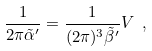Convert formula to latex. <formula><loc_0><loc_0><loc_500><loc_500>\frac { 1 } { 2 \pi { \tilde { \alpha } } ^ { \prime } } = \frac { 1 } { ( 2 \pi ) ^ { 3 } { \tilde { \beta } } ^ { \prime } } V \ ,</formula> 